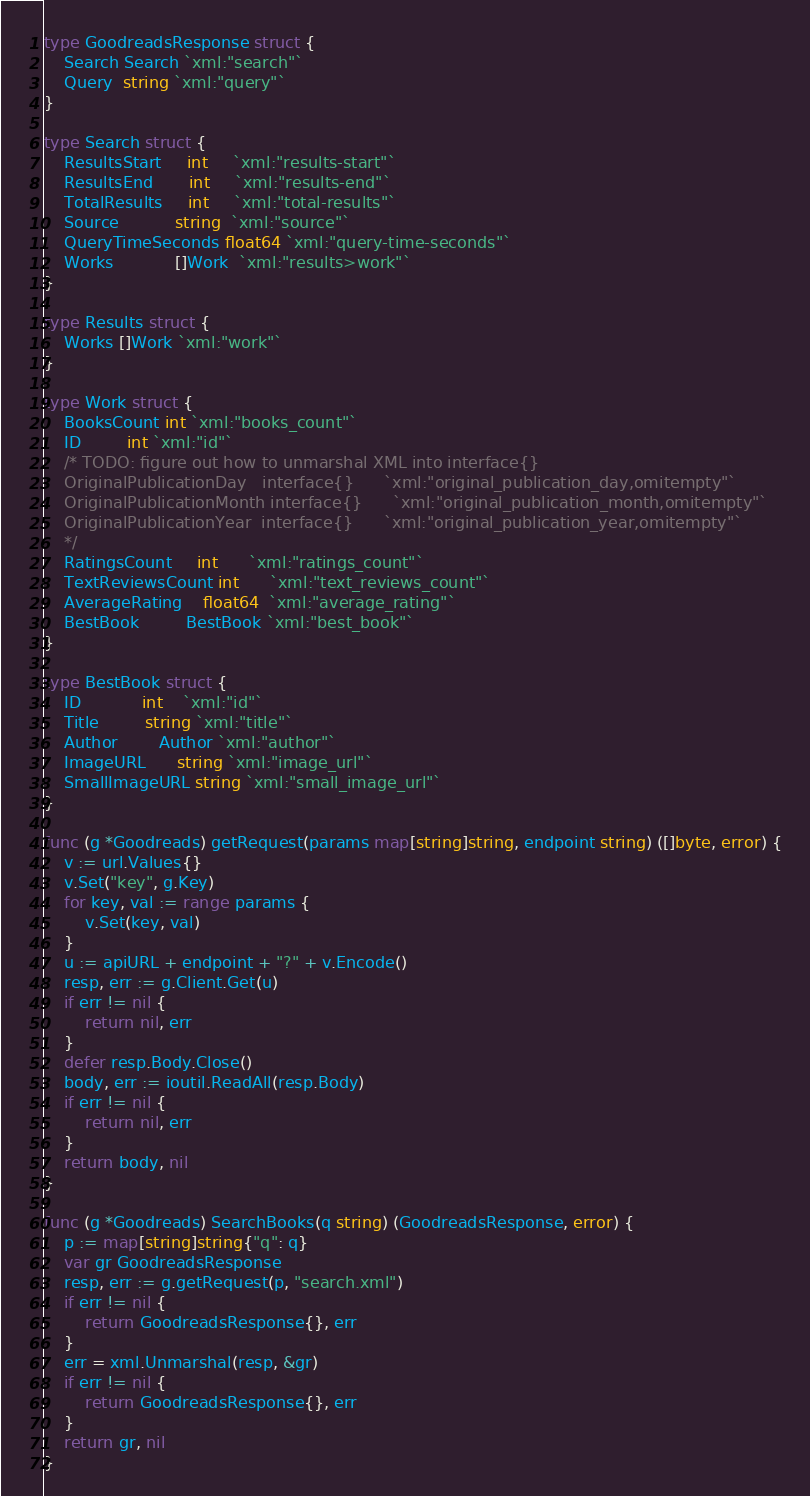<code> <loc_0><loc_0><loc_500><loc_500><_Go_>type GoodreadsResponse struct {
	Search Search `xml:"search"`
	Query  string `xml:"query"`
}

type Search struct {
	ResultsStart     int     `xml:"results-start"`
	ResultsEnd       int     `xml:"results-end"`
	TotalResults     int     `xml:"total-results"`
	Source           string  `xml:"source"`
	QueryTimeSeconds float64 `xml:"query-time-seconds"`
	Works            []Work  `xml:"results>work"`
}

type Results struct {
	Works []Work `xml:"work"`
}

type Work struct {
	BooksCount int `xml:"books_count"`
	ID         int `xml:"id"`
	/* TODO: figure out how to unmarshal XML into interface{}
	OriginalPublicationDay   interface{}      `xml:"original_publication_day,omitempty"`
	OriginalPublicationMonth interface{}      `xml:"original_publication_month,omitempty"`
	OriginalPublicationYear  interface{}      `xml:"original_publication_year,omitempty"`
	*/
	RatingsCount     int      `xml:"ratings_count"`
	TextReviewsCount int      `xml:"text_reviews_count"`
	AverageRating    float64  `xml:"average_rating"`
	BestBook         BestBook `xml:"best_book"`
}

type BestBook struct {
	ID            int    `xml:"id"`
	Title         string `xml:"title"`
	Author        Author `xml:"author"`
	ImageURL      string `xml:"image_url"`
	SmallImageURL string `xml:"small_image_url"`
}

func (g *Goodreads) getRequest(params map[string]string, endpoint string) ([]byte, error) {
	v := url.Values{}
	v.Set("key", g.Key)
	for key, val := range params {
		v.Set(key, val)
	}
	u := apiURL + endpoint + "?" + v.Encode()
	resp, err := g.Client.Get(u)
	if err != nil {
		return nil, err
	}
	defer resp.Body.Close()
	body, err := ioutil.ReadAll(resp.Body)
	if err != nil {
		return nil, err
	}
	return body, nil
}

func (g *Goodreads) SearchBooks(q string) (GoodreadsResponse, error) {
	p := map[string]string{"q": q}
	var gr GoodreadsResponse
	resp, err := g.getRequest(p, "search.xml")
	if err != nil {
		return GoodreadsResponse{}, err
	}
	err = xml.Unmarshal(resp, &gr)
	if err != nil {
		return GoodreadsResponse{}, err
	}
	return gr, nil
}
</code> 